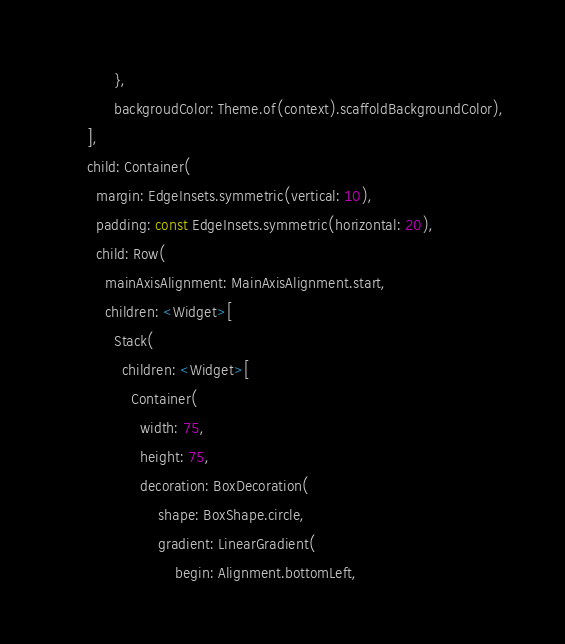<code> <loc_0><loc_0><loc_500><loc_500><_Dart_>            },
            backgroudColor: Theme.of(context).scaffoldBackgroundColor),
      ],
      child: Container(
        margin: EdgeInsets.symmetric(vertical: 10),
        padding: const EdgeInsets.symmetric(horizontal: 20),
        child: Row(
          mainAxisAlignment: MainAxisAlignment.start,
          children: <Widget>[
            Stack(
              children: <Widget>[
                Container(
                  width: 75,
                  height: 75,
                  decoration: BoxDecoration(
                      shape: BoxShape.circle,
                      gradient: LinearGradient(
                          begin: Alignment.bottomLeft,</code> 